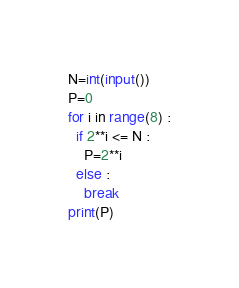<code> <loc_0><loc_0><loc_500><loc_500><_Python_>N=int(input())
P=0
for i in range(8) :
  if 2**i <= N : 
    P=2**i 
  else :
    break
print(P)</code> 